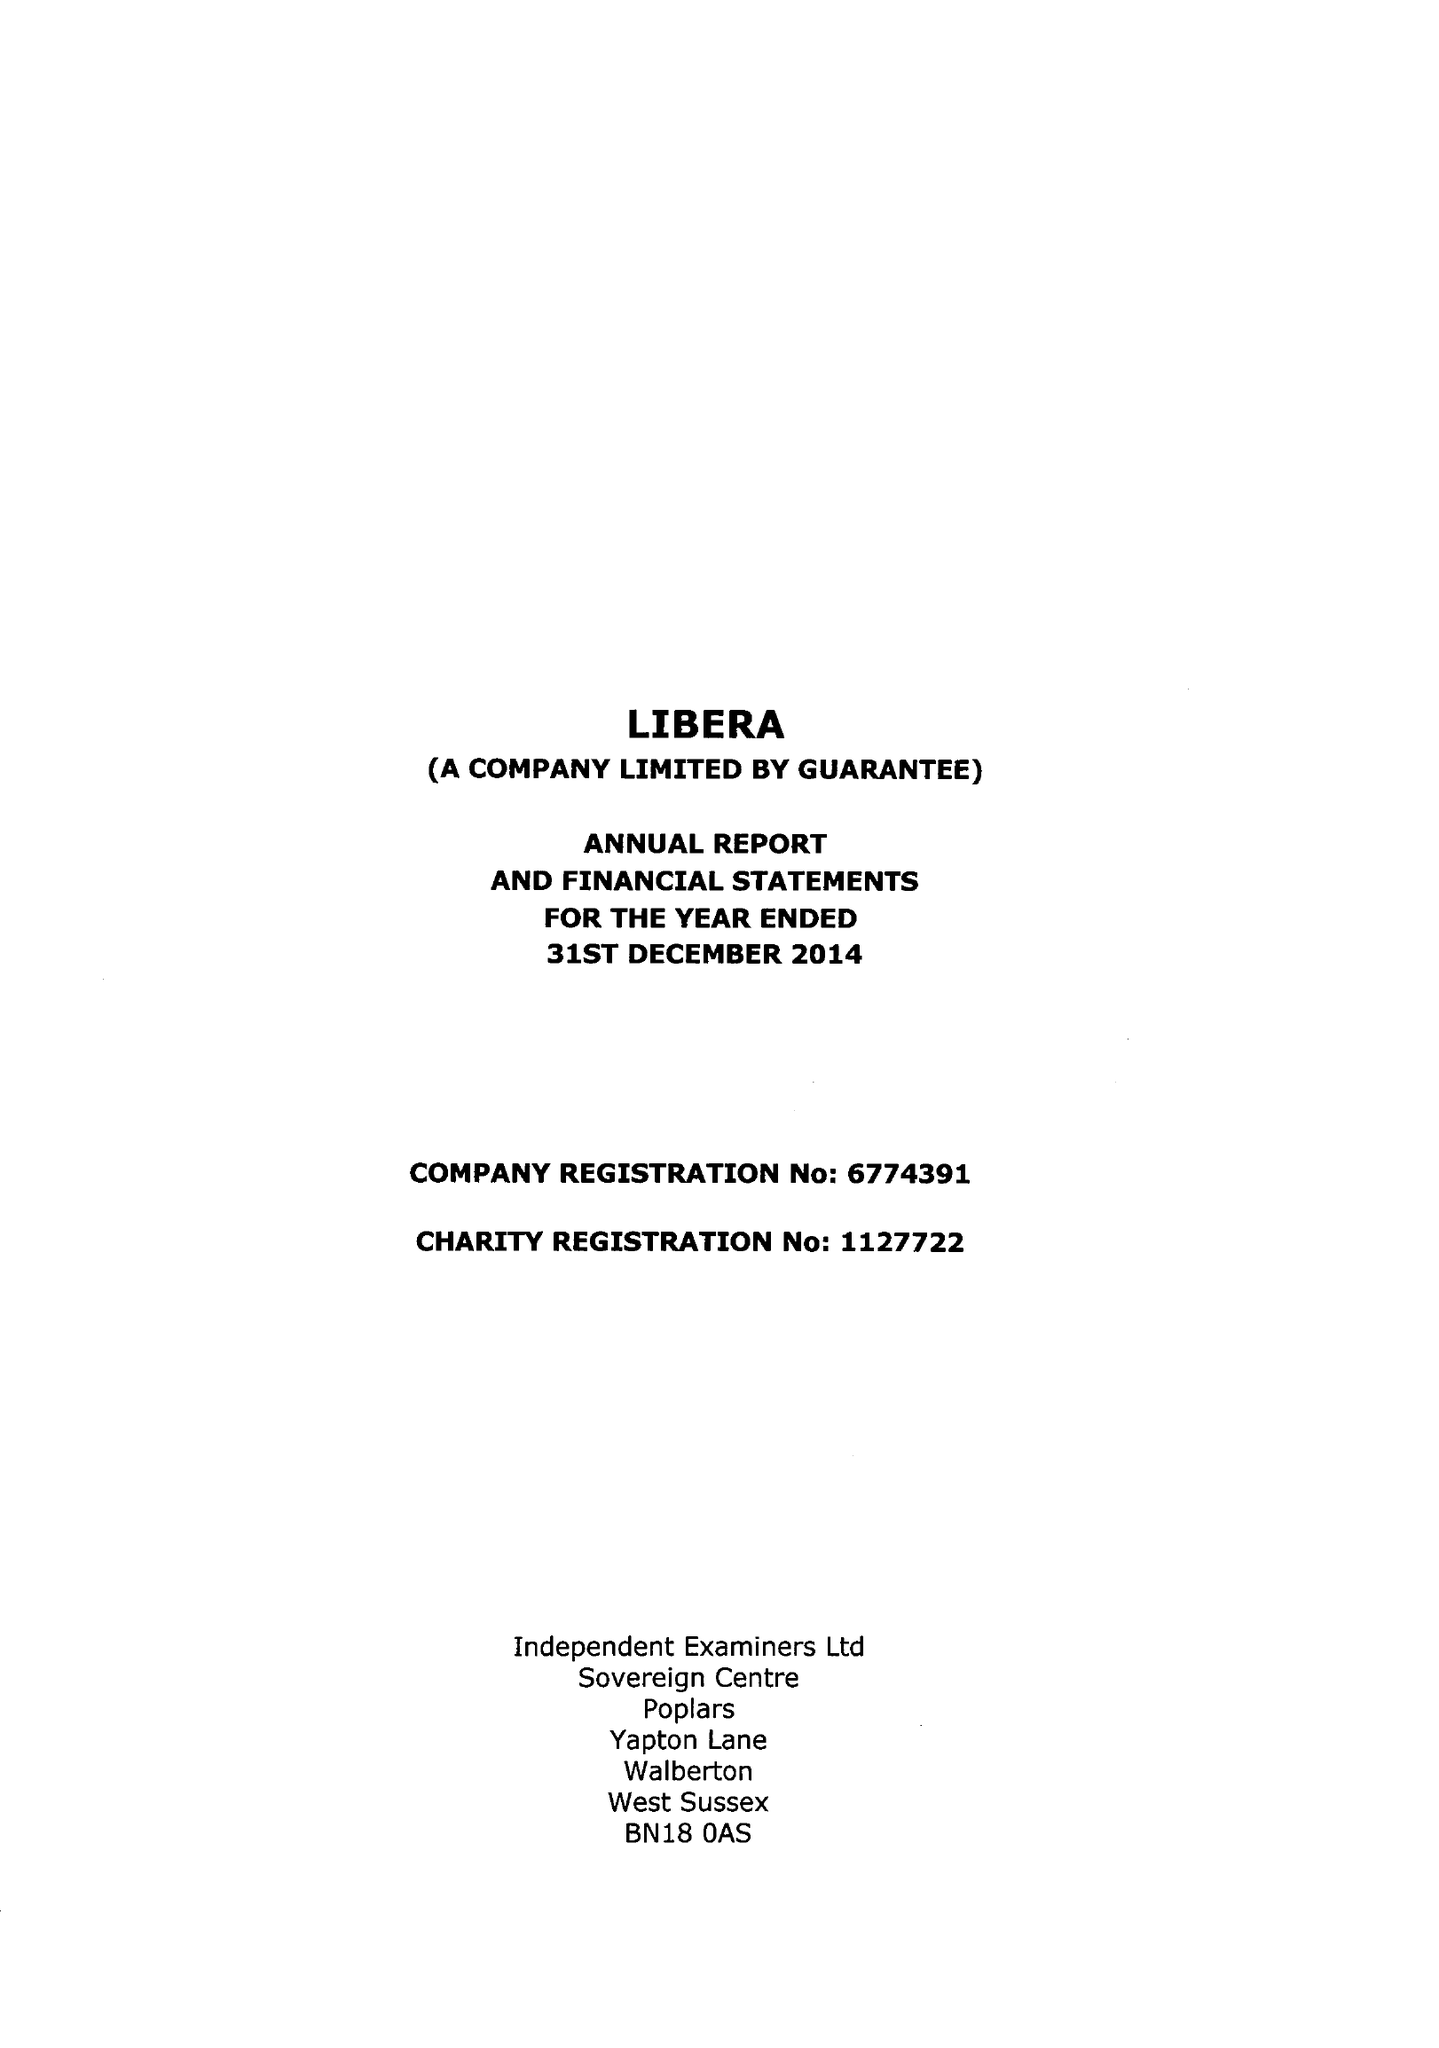What is the value for the address__postcode?
Answer the question using a single word or phrase. CR0 8AU 